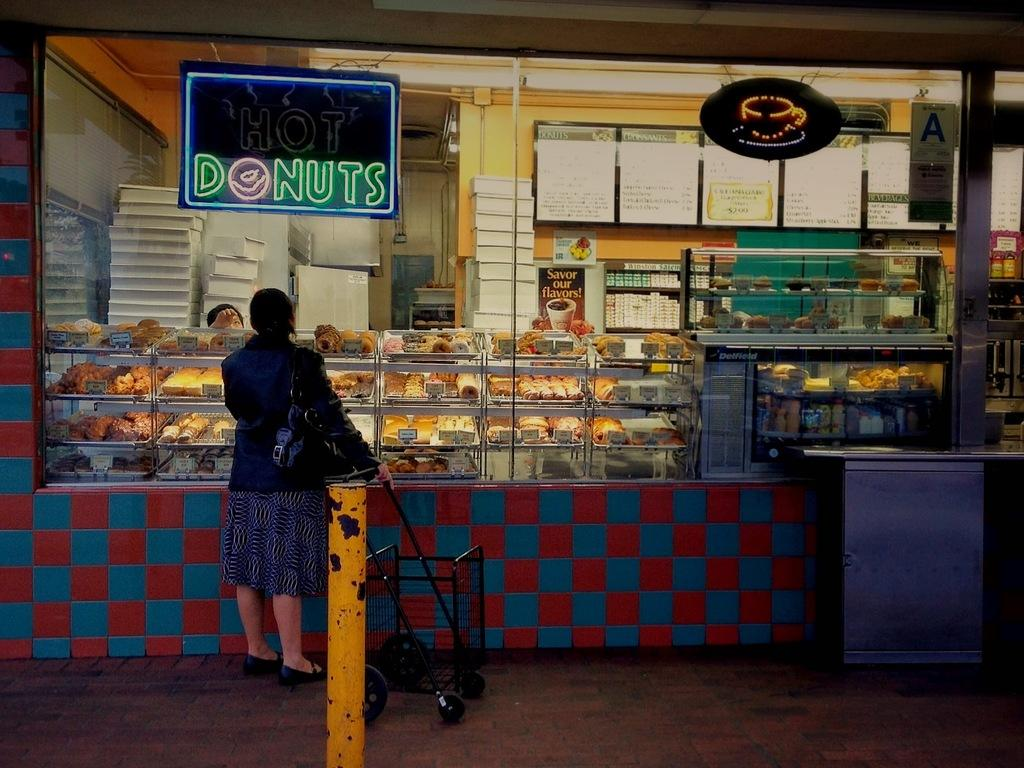<image>
Offer a succinct explanation of the picture presented. The front of a food stand where a sign says Donuts are served. 